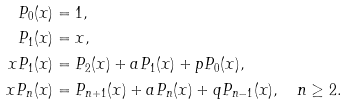Convert formula to latex. <formula><loc_0><loc_0><loc_500><loc_500>P _ { 0 } ( x ) & = 1 , \\ P _ { 1 } ( x ) & = x , \\ x P _ { 1 } ( x ) & = P _ { 2 } ( x ) + a P _ { 1 } ( x ) + p P _ { 0 } ( x ) , \\ x P _ { n } ( x ) & = P _ { n + 1 } ( x ) + a P _ { n } ( x ) + q P _ { n - 1 } ( x ) , \quad n \geq 2 .</formula> 